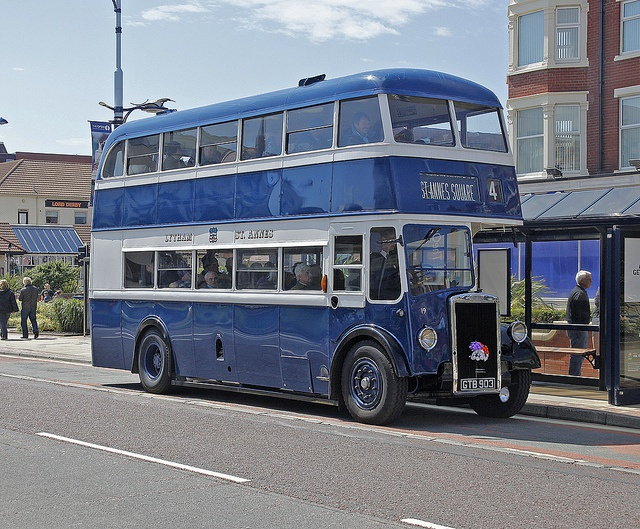Describe the objects in this image and their specific colors. I can see bus in lightblue, black, navy, gray, and darkgray tones, people in lightblue, black, gray, and maroon tones, people in lightblue, gray, blue, darkblue, and navy tones, people in lightblue, black, gray, and darkgray tones, and people in lightblue, black, and gray tones in this image. 